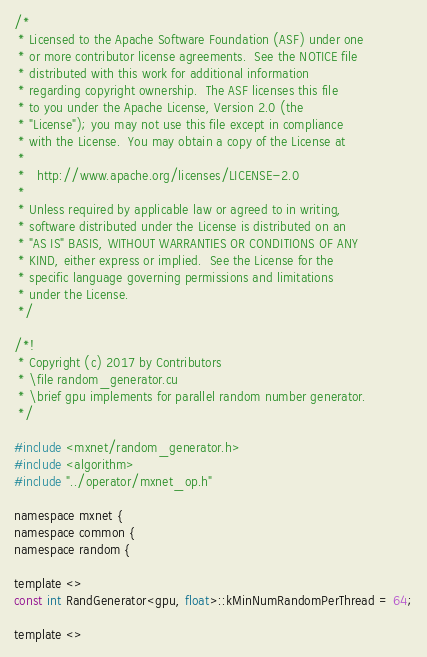Convert code to text. <code><loc_0><loc_0><loc_500><loc_500><_Cuda_>/*
 * Licensed to the Apache Software Foundation (ASF) under one
 * or more contributor license agreements.  See the NOTICE file
 * distributed with this work for additional information
 * regarding copyright ownership.  The ASF licenses this file
 * to you under the Apache License, Version 2.0 (the
 * "License"); you may not use this file except in compliance
 * with the License.  You may obtain a copy of the License at
 *
 *   http://www.apache.org/licenses/LICENSE-2.0
 *
 * Unless required by applicable law or agreed to in writing,
 * software distributed under the License is distributed on an
 * "AS IS" BASIS, WITHOUT WARRANTIES OR CONDITIONS OF ANY
 * KIND, either express or implied.  See the License for the
 * specific language governing permissions and limitations
 * under the License.
 */

/*!
 * Copyright (c) 2017 by Contributors
 * \file random_generator.cu
 * \brief gpu implements for parallel random number generator.
 */

#include <mxnet/random_generator.h>
#include <algorithm>
#include "../operator/mxnet_op.h"

namespace mxnet {
namespace common {
namespace random {

template <>
const int RandGenerator<gpu, float>::kMinNumRandomPerThread = 64;

template <></code> 